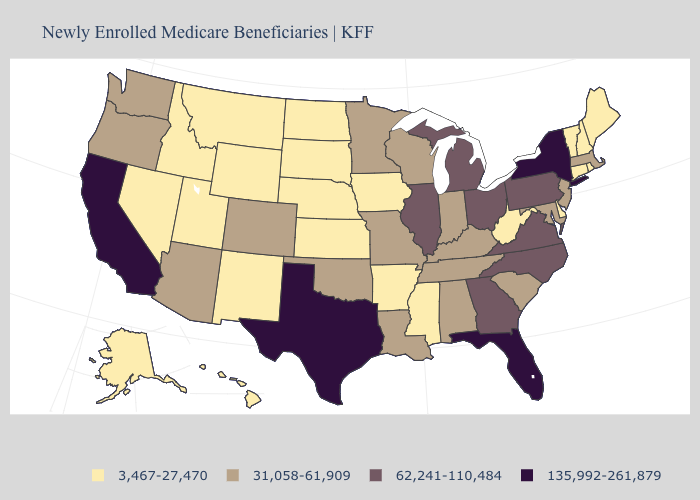What is the lowest value in the USA?
Concise answer only. 3,467-27,470. Name the states that have a value in the range 3,467-27,470?
Be succinct. Alaska, Arkansas, Connecticut, Delaware, Hawaii, Idaho, Iowa, Kansas, Maine, Mississippi, Montana, Nebraska, Nevada, New Hampshire, New Mexico, North Dakota, Rhode Island, South Dakota, Utah, Vermont, West Virginia, Wyoming. Does New York have the highest value in the USA?
Give a very brief answer. Yes. What is the value of New Hampshire?
Short answer required. 3,467-27,470. Does the first symbol in the legend represent the smallest category?
Keep it brief. Yes. Does North Carolina have the lowest value in the South?
Concise answer only. No. Among the states that border Michigan , which have the highest value?
Keep it brief. Ohio. Name the states that have a value in the range 135,992-261,879?
Short answer required. California, Florida, New York, Texas. What is the value of South Carolina?
Give a very brief answer. 31,058-61,909. What is the value of New York?
Write a very short answer. 135,992-261,879. Among the states that border New York , which have the lowest value?
Concise answer only. Connecticut, Vermont. Name the states that have a value in the range 62,241-110,484?
Concise answer only. Georgia, Illinois, Michigan, North Carolina, Ohio, Pennsylvania, Virginia. What is the value of Alaska?
Write a very short answer. 3,467-27,470. Is the legend a continuous bar?
Be succinct. No. How many symbols are there in the legend?
Give a very brief answer. 4. 